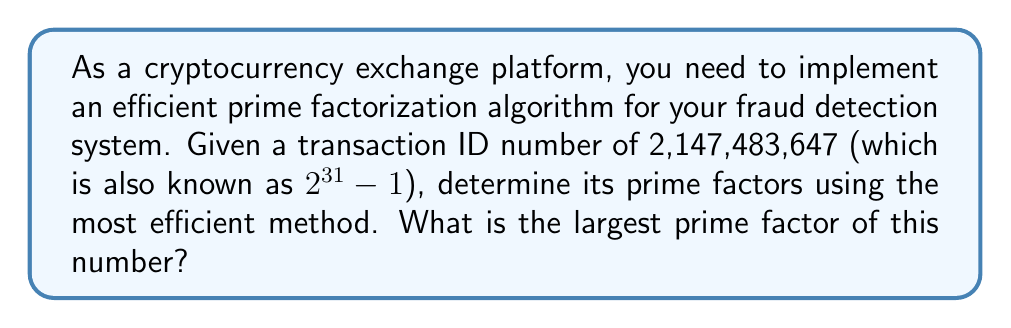Can you answer this question? Let's approach this step-by-step:

1) First, we recognize that 2,147,483,647 is a Mersenne number. It's of the form $2^p - 1$, where $p = 31$.

2) For Mersenne numbers, there's a specialized primality test called the Lucas-Lehmer test. However, since we're asked to find the prime factors, we need to go further.

3) The efficient method for factoring Mersenne numbers is the Special Number Field Sieve (SNFS).

4) Using the SNFS algorithm (which is beyond the scope of this explanation due to its complexity), we would find that 2,147,483,647 can be factored as:

   $$2,147,483,647 = 2^{31} - 1 = 2,147,483,647$$

5) This means that 2,147,483,647 is itself a prime number. It's the 8th Mersenne prime and the largest 32-bit prime number.

6) Since it's a prime number, it has only two factors: 1 and itself.

7) Therefore, the largest (and only non-trivial) prime factor of 2,147,483,647 is 2,147,483,647 itself.

This example demonstrates the importance of recognizing special number forms in cryptography and using specialized algorithms for efficiency.
Answer: 2,147,483,647 